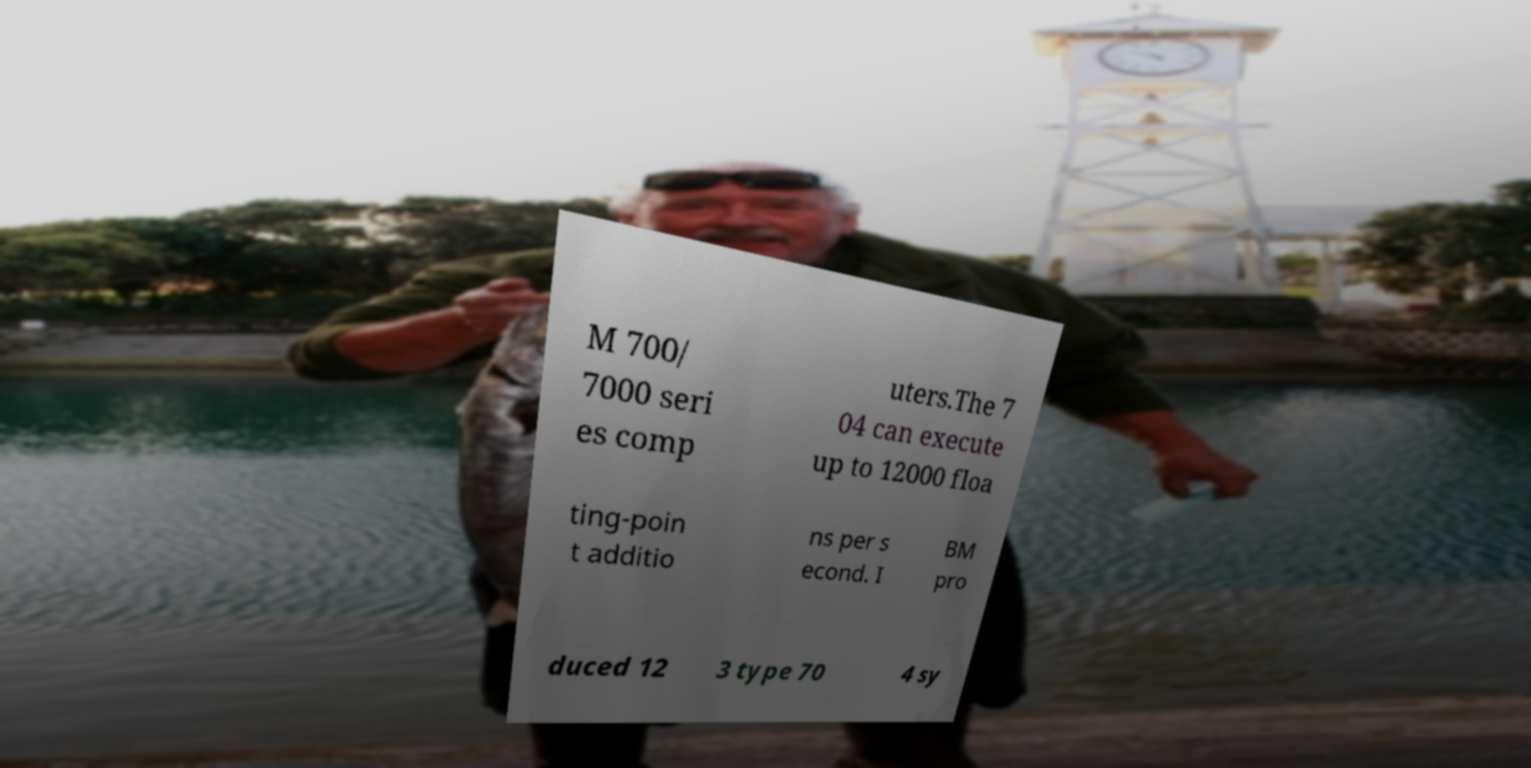Could you extract and type out the text from this image? M 700/ 7000 seri es comp uters.The 7 04 can execute up to 12000 floa ting-poin t additio ns per s econd. I BM pro duced 12 3 type 70 4 sy 